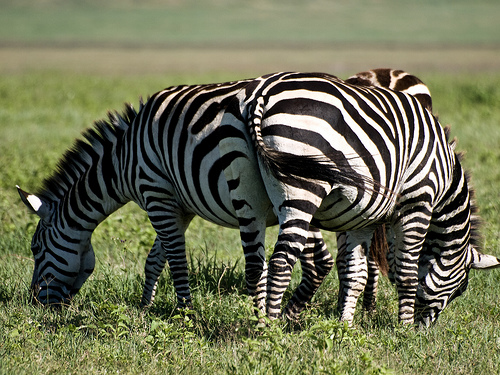Are there zebras to the left of the person?
Answer the question using a single word or phrase. Yes 